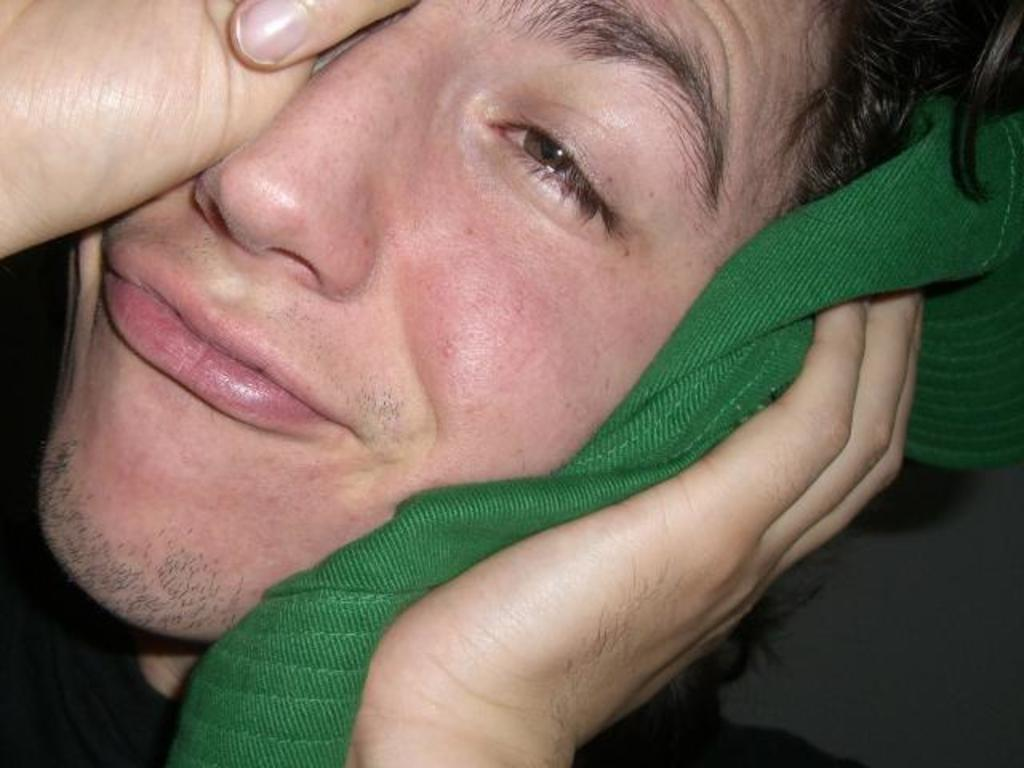What is the main subject of the image? There is a person in the image. What is the person doing in the image? The person is crying. What type of ornament is hanging from the church in the image? There is no church or ornament present in the image; it only features a person who is crying. How many ornaments are visible in the image? There are no ornaments present in the image. 